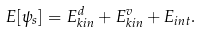<formula> <loc_0><loc_0><loc_500><loc_500>E [ \psi _ { s } ] = E _ { k i n } ^ { d } + E _ { k i n } ^ { v } + E _ { i n t } .</formula> 